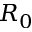Convert formula to latex. <formula><loc_0><loc_0><loc_500><loc_500>R _ { 0 }</formula> 